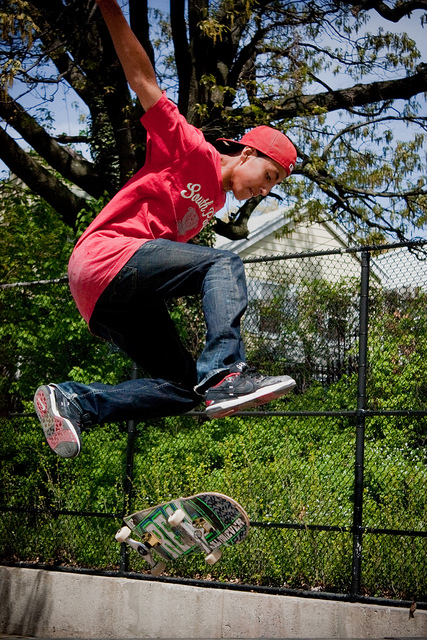Please transcribe the text information in this image. South 